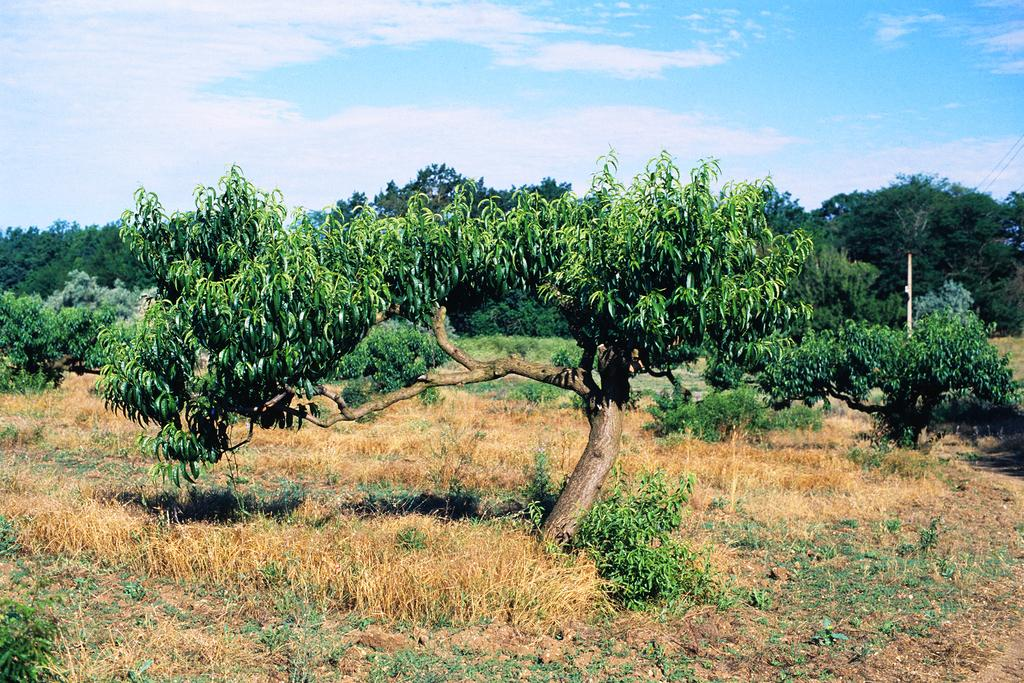What type of vegetation can be seen in the image? There are trees and plants in the image. What is on the ground in the image? There is grass and plants on the ground in the image. What is visible at the top of the image? The sky is visible at the top of the image. Can you see a nest in the trees in the image? There is no nest visible in the trees in the image. What type of transport is present in the image? There is no transport present in the image; it features trees, plants, grass, and the sky. 